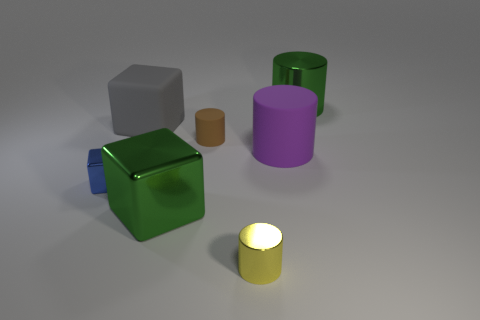Subtract all big blocks. How many blocks are left? 1 Add 2 blue shiny blocks. How many objects exist? 9 Subtract all cubes. How many objects are left? 4 Subtract all purple blocks. Subtract all red cylinders. How many blocks are left? 3 Subtract all red blocks. How many purple cylinders are left? 1 Subtract all large yellow blocks. Subtract all big green shiny cylinders. How many objects are left? 6 Add 1 matte cylinders. How many matte cylinders are left? 3 Add 3 blocks. How many blocks exist? 6 Subtract all green cylinders. How many cylinders are left? 3 Subtract 1 green cubes. How many objects are left? 6 